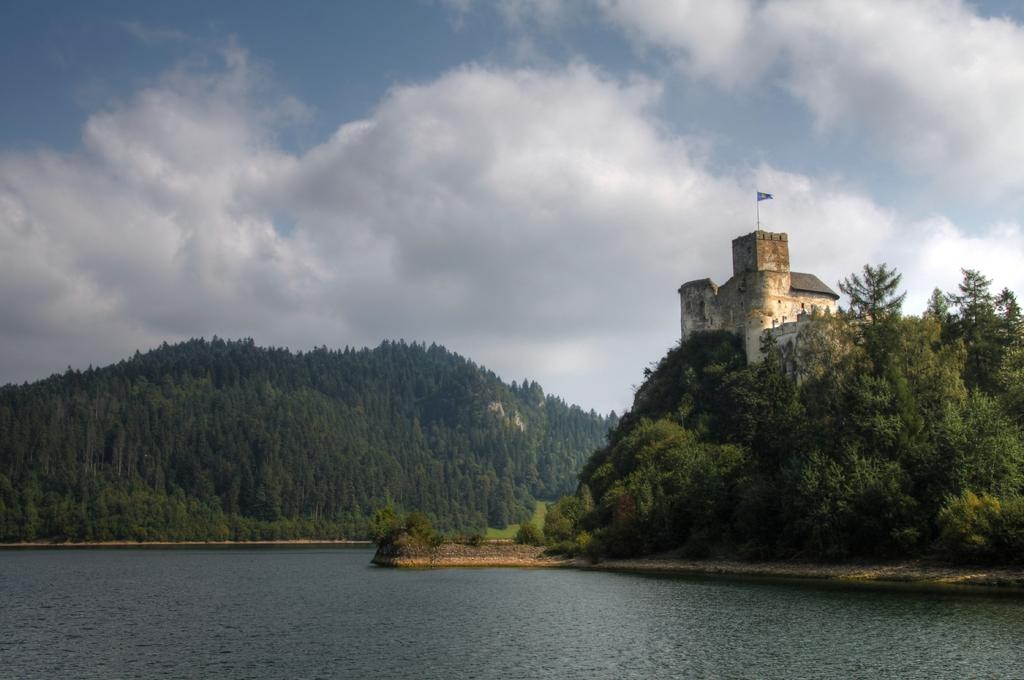What can be seen in the sky in the image? The sky with clouds is visible in the image. What type of natural landforms are present in the image? There are hills in the image. What type of vegetation is present in the image? There are trees in the image. What type of man-made structure is present in the image? There is a building in the image. What type of symbol is present in the image? There is a flag in the image. What is the flag attached to in the image? There is a flag post in the image. What type of water body is present in the image? There is a lake in the image. How does the flag kick the ball in the image? The flag does not kick a ball in the image; it is simply attached to the flag post. What type of wound is visible on the trees in the image? There are no wounds visible on the trees in the image. 